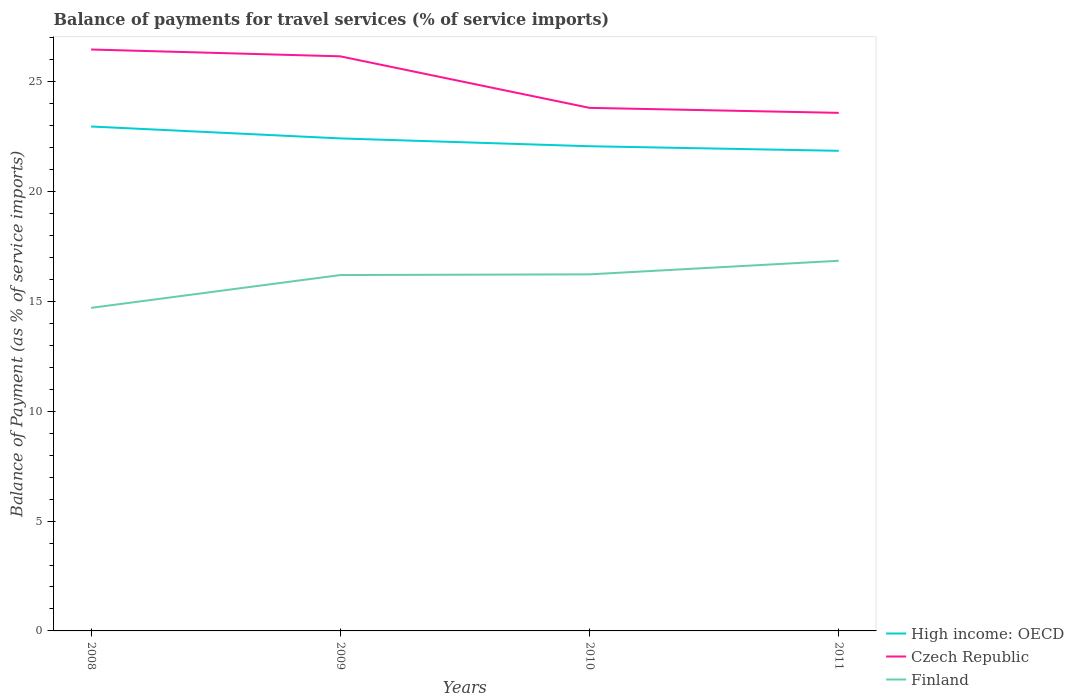Is the number of lines equal to the number of legend labels?
Provide a short and direct response. Yes. Across all years, what is the maximum balance of payments for travel services in High income: OECD?
Your answer should be very brief. 21.85. What is the total balance of payments for travel services in Czech Republic in the graph?
Your answer should be very brief. 0.31. What is the difference between the highest and the second highest balance of payments for travel services in Finland?
Your answer should be very brief. 2.14. Is the balance of payments for travel services in Finland strictly greater than the balance of payments for travel services in Czech Republic over the years?
Keep it short and to the point. Yes. How many lines are there?
Offer a very short reply. 3. Does the graph contain any zero values?
Provide a short and direct response. No. How are the legend labels stacked?
Make the answer very short. Vertical. What is the title of the graph?
Ensure brevity in your answer.  Balance of payments for travel services (% of service imports). Does "Angola" appear as one of the legend labels in the graph?
Offer a very short reply. No. What is the label or title of the Y-axis?
Offer a terse response. Balance of Payment (as % of service imports). What is the Balance of Payment (as % of service imports) of High income: OECD in 2008?
Offer a terse response. 22.96. What is the Balance of Payment (as % of service imports) of Czech Republic in 2008?
Provide a succinct answer. 26.46. What is the Balance of Payment (as % of service imports) in Finland in 2008?
Provide a succinct answer. 14.7. What is the Balance of Payment (as % of service imports) in High income: OECD in 2009?
Provide a short and direct response. 22.41. What is the Balance of Payment (as % of service imports) in Czech Republic in 2009?
Your response must be concise. 26.15. What is the Balance of Payment (as % of service imports) of Finland in 2009?
Provide a succinct answer. 16.2. What is the Balance of Payment (as % of service imports) of High income: OECD in 2010?
Your response must be concise. 22.06. What is the Balance of Payment (as % of service imports) of Czech Republic in 2010?
Provide a short and direct response. 23.8. What is the Balance of Payment (as % of service imports) of Finland in 2010?
Provide a succinct answer. 16.23. What is the Balance of Payment (as % of service imports) in High income: OECD in 2011?
Ensure brevity in your answer.  21.85. What is the Balance of Payment (as % of service imports) of Czech Republic in 2011?
Provide a succinct answer. 23.58. What is the Balance of Payment (as % of service imports) of Finland in 2011?
Give a very brief answer. 16.85. Across all years, what is the maximum Balance of Payment (as % of service imports) of High income: OECD?
Provide a succinct answer. 22.96. Across all years, what is the maximum Balance of Payment (as % of service imports) in Czech Republic?
Provide a short and direct response. 26.46. Across all years, what is the maximum Balance of Payment (as % of service imports) of Finland?
Keep it short and to the point. 16.85. Across all years, what is the minimum Balance of Payment (as % of service imports) in High income: OECD?
Your answer should be very brief. 21.85. Across all years, what is the minimum Balance of Payment (as % of service imports) in Czech Republic?
Your response must be concise. 23.58. Across all years, what is the minimum Balance of Payment (as % of service imports) in Finland?
Give a very brief answer. 14.7. What is the total Balance of Payment (as % of service imports) of High income: OECD in the graph?
Offer a terse response. 89.28. What is the total Balance of Payment (as % of service imports) in Czech Republic in the graph?
Your answer should be compact. 99.99. What is the total Balance of Payment (as % of service imports) in Finland in the graph?
Give a very brief answer. 63.97. What is the difference between the Balance of Payment (as % of service imports) of High income: OECD in 2008 and that in 2009?
Keep it short and to the point. 0.54. What is the difference between the Balance of Payment (as % of service imports) in Czech Republic in 2008 and that in 2009?
Make the answer very short. 0.31. What is the difference between the Balance of Payment (as % of service imports) of Finland in 2008 and that in 2009?
Offer a terse response. -1.49. What is the difference between the Balance of Payment (as % of service imports) in High income: OECD in 2008 and that in 2010?
Your response must be concise. 0.9. What is the difference between the Balance of Payment (as % of service imports) of Czech Republic in 2008 and that in 2010?
Offer a very short reply. 2.66. What is the difference between the Balance of Payment (as % of service imports) of Finland in 2008 and that in 2010?
Your answer should be compact. -1.53. What is the difference between the Balance of Payment (as % of service imports) in High income: OECD in 2008 and that in 2011?
Offer a very short reply. 1.11. What is the difference between the Balance of Payment (as % of service imports) of Czech Republic in 2008 and that in 2011?
Your response must be concise. 2.88. What is the difference between the Balance of Payment (as % of service imports) of Finland in 2008 and that in 2011?
Provide a succinct answer. -2.14. What is the difference between the Balance of Payment (as % of service imports) in High income: OECD in 2009 and that in 2010?
Your response must be concise. 0.36. What is the difference between the Balance of Payment (as % of service imports) in Czech Republic in 2009 and that in 2010?
Offer a terse response. 2.34. What is the difference between the Balance of Payment (as % of service imports) of Finland in 2009 and that in 2010?
Keep it short and to the point. -0.03. What is the difference between the Balance of Payment (as % of service imports) of High income: OECD in 2009 and that in 2011?
Provide a succinct answer. 0.56. What is the difference between the Balance of Payment (as % of service imports) of Czech Republic in 2009 and that in 2011?
Ensure brevity in your answer.  2.57. What is the difference between the Balance of Payment (as % of service imports) of Finland in 2009 and that in 2011?
Your answer should be compact. -0.65. What is the difference between the Balance of Payment (as % of service imports) in High income: OECD in 2010 and that in 2011?
Provide a succinct answer. 0.21. What is the difference between the Balance of Payment (as % of service imports) of Czech Republic in 2010 and that in 2011?
Your answer should be very brief. 0.23. What is the difference between the Balance of Payment (as % of service imports) of Finland in 2010 and that in 2011?
Offer a very short reply. -0.62. What is the difference between the Balance of Payment (as % of service imports) of High income: OECD in 2008 and the Balance of Payment (as % of service imports) of Czech Republic in 2009?
Ensure brevity in your answer.  -3.19. What is the difference between the Balance of Payment (as % of service imports) in High income: OECD in 2008 and the Balance of Payment (as % of service imports) in Finland in 2009?
Offer a very short reply. 6.76. What is the difference between the Balance of Payment (as % of service imports) in Czech Republic in 2008 and the Balance of Payment (as % of service imports) in Finland in 2009?
Make the answer very short. 10.27. What is the difference between the Balance of Payment (as % of service imports) of High income: OECD in 2008 and the Balance of Payment (as % of service imports) of Czech Republic in 2010?
Offer a very short reply. -0.85. What is the difference between the Balance of Payment (as % of service imports) in High income: OECD in 2008 and the Balance of Payment (as % of service imports) in Finland in 2010?
Offer a very short reply. 6.73. What is the difference between the Balance of Payment (as % of service imports) of Czech Republic in 2008 and the Balance of Payment (as % of service imports) of Finland in 2010?
Make the answer very short. 10.23. What is the difference between the Balance of Payment (as % of service imports) in High income: OECD in 2008 and the Balance of Payment (as % of service imports) in Czech Republic in 2011?
Keep it short and to the point. -0.62. What is the difference between the Balance of Payment (as % of service imports) in High income: OECD in 2008 and the Balance of Payment (as % of service imports) in Finland in 2011?
Ensure brevity in your answer.  6.11. What is the difference between the Balance of Payment (as % of service imports) of Czech Republic in 2008 and the Balance of Payment (as % of service imports) of Finland in 2011?
Your answer should be compact. 9.62. What is the difference between the Balance of Payment (as % of service imports) in High income: OECD in 2009 and the Balance of Payment (as % of service imports) in Czech Republic in 2010?
Keep it short and to the point. -1.39. What is the difference between the Balance of Payment (as % of service imports) of High income: OECD in 2009 and the Balance of Payment (as % of service imports) of Finland in 2010?
Offer a very short reply. 6.19. What is the difference between the Balance of Payment (as % of service imports) in Czech Republic in 2009 and the Balance of Payment (as % of service imports) in Finland in 2010?
Your answer should be very brief. 9.92. What is the difference between the Balance of Payment (as % of service imports) in High income: OECD in 2009 and the Balance of Payment (as % of service imports) in Czech Republic in 2011?
Your answer should be very brief. -1.16. What is the difference between the Balance of Payment (as % of service imports) of High income: OECD in 2009 and the Balance of Payment (as % of service imports) of Finland in 2011?
Offer a very short reply. 5.57. What is the difference between the Balance of Payment (as % of service imports) in Czech Republic in 2009 and the Balance of Payment (as % of service imports) in Finland in 2011?
Provide a short and direct response. 9.3. What is the difference between the Balance of Payment (as % of service imports) of High income: OECD in 2010 and the Balance of Payment (as % of service imports) of Czech Republic in 2011?
Offer a terse response. -1.52. What is the difference between the Balance of Payment (as % of service imports) in High income: OECD in 2010 and the Balance of Payment (as % of service imports) in Finland in 2011?
Keep it short and to the point. 5.21. What is the difference between the Balance of Payment (as % of service imports) in Czech Republic in 2010 and the Balance of Payment (as % of service imports) in Finland in 2011?
Your response must be concise. 6.96. What is the average Balance of Payment (as % of service imports) of High income: OECD per year?
Make the answer very short. 22.32. What is the average Balance of Payment (as % of service imports) in Czech Republic per year?
Provide a succinct answer. 25. What is the average Balance of Payment (as % of service imports) of Finland per year?
Give a very brief answer. 15.99. In the year 2008, what is the difference between the Balance of Payment (as % of service imports) in High income: OECD and Balance of Payment (as % of service imports) in Czech Republic?
Your answer should be compact. -3.5. In the year 2008, what is the difference between the Balance of Payment (as % of service imports) in High income: OECD and Balance of Payment (as % of service imports) in Finland?
Provide a succinct answer. 8.25. In the year 2008, what is the difference between the Balance of Payment (as % of service imports) of Czech Republic and Balance of Payment (as % of service imports) of Finland?
Offer a terse response. 11.76. In the year 2009, what is the difference between the Balance of Payment (as % of service imports) in High income: OECD and Balance of Payment (as % of service imports) in Czech Republic?
Your answer should be compact. -3.74. In the year 2009, what is the difference between the Balance of Payment (as % of service imports) of High income: OECD and Balance of Payment (as % of service imports) of Finland?
Your response must be concise. 6.22. In the year 2009, what is the difference between the Balance of Payment (as % of service imports) in Czech Republic and Balance of Payment (as % of service imports) in Finland?
Provide a succinct answer. 9.95. In the year 2010, what is the difference between the Balance of Payment (as % of service imports) of High income: OECD and Balance of Payment (as % of service imports) of Czech Republic?
Make the answer very short. -1.75. In the year 2010, what is the difference between the Balance of Payment (as % of service imports) of High income: OECD and Balance of Payment (as % of service imports) of Finland?
Your answer should be compact. 5.83. In the year 2010, what is the difference between the Balance of Payment (as % of service imports) in Czech Republic and Balance of Payment (as % of service imports) in Finland?
Your response must be concise. 7.58. In the year 2011, what is the difference between the Balance of Payment (as % of service imports) in High income: OECD and Balance of Payment (as % of service imports) in Czech Republic?
Provide a succinct answer. -1.73. In the year 2011, what is the difference between the Balance of Payment (as % of service imports) in High income: OECD and Balance of Payment (as % of service imports) in Finland?
Keep it short and to the point. 5. In the year 2011, what is the difference between the Balance of Payment (as % of service imports) in Czech Republic and Balance of Payment (as % of service imports) in Finland?
Offer a very short reply. 6.73. What is the ratio of the Balance of Payment (as % of service imports) in High income: OECD in 2008 to that in 2009?
Your response must be concise. 1.02. What is the ratio of the Balance of Payment (as % of service imports) in Czech Republic in 2008 to that in 2009?
Your answer should be compact. 1.01. What is the ratio of the Balance of Payment (as % of service imports) in Finland in 2008 to that in 2009?
Make the answer very short. 0.91. What is the ratio of the Balance of Payment (as % of service imports) in High income: OECD in 2008 to that in 2010?
Make the answer very short. 1.04. What is the ratio of the Balance of Payment (as % of service imports) in Czech Republic in 2008 to that in 2010?
Make the answer very short. 1.11. What is the ratio of the Balance of Payment (as % of service imports) of Finland in 2008 to that in 2010?
Provide a succinct answer. 0.91. What is the ratio of the Balance of Payment (as % of service imports) of High income: OECD in 2008 to that in 2011?
Provide a short and direct response. 1.05. What is the ratio of the Balance of Payment (as % of service imports) of Czech Republic in 2008 to that in 2011?
Provide a succinct answer. 1.12. What is the ratio of the Balance of Payment (as % of service imports) in Finland in 2008 to that in 2011?
Your answer should be very brief. 0.87. What is the ratio of the Balance of Payment (as % of service imports) in High income: OECD in 2009 to that in 2010?
Your answer should be very brief. 1.02. What is the ratio of the Balance of Payment (as % of service imports) of Czech Republic in 2009 to that in 2010?
Provide a succinct answer. 1.1. What is the ratio of the Balance of Payment (as % of service imports) in High income: OECD in 2009 to that in 2011?
Make the answer very short. 1.03. What is the ratio of the Balance of Payment (as % of service imports) of Czech Republic in 2009 to that in 2011?
Your answer should be very brief. 1.11. What is the ratio of the Balance of Payment (as % of service imports) of Finland in 2009 to that in 2011?
Your response must be concise. 0.96. What is the ratio of the Balance of Payment (as % of service imports) of High income: OECD in 2010 to that in 2011?
Offer a terse response. 1.01. What is the ratio of the Balance of Payment (as % of service imports) of Czech Republic in 2010 to that in 2011?
Your answer should be very brief. 1.01. What is the ratio of the Balance of Payment (as % of service imports) of Finland in 2010 to that in 2011?
Your answer should be compact. 0.96. What is the difference between the highest and the second highest Balance of Payment (as % of service imports) in High income: OECD?
Ensure brevity in your answer.  0.54. What is the difference between the highest and the second highest Balance of Payment (as % of service imports) in Czech Republic?
Your answer should be compact. 0.31. What is the difference between the highest and the second highest Balance of Payment (as % of service imports) in Finland?
Keep it short and to the point. 0.62. What is the difference between the highest and the lowest Balance of Payment (as % of service imports) in High income: OECD?
Offer a terse response. 1.11. What is the difference between the highest and the lowest Balance of Payment (as % of service imports) in Czech Republic?
Provide a short and direct response. 2.88. What is the difference between the highest and the lowest Balance of Payment (as % of service imports) of Finland?
Provide a short and direct response. 2.14. 